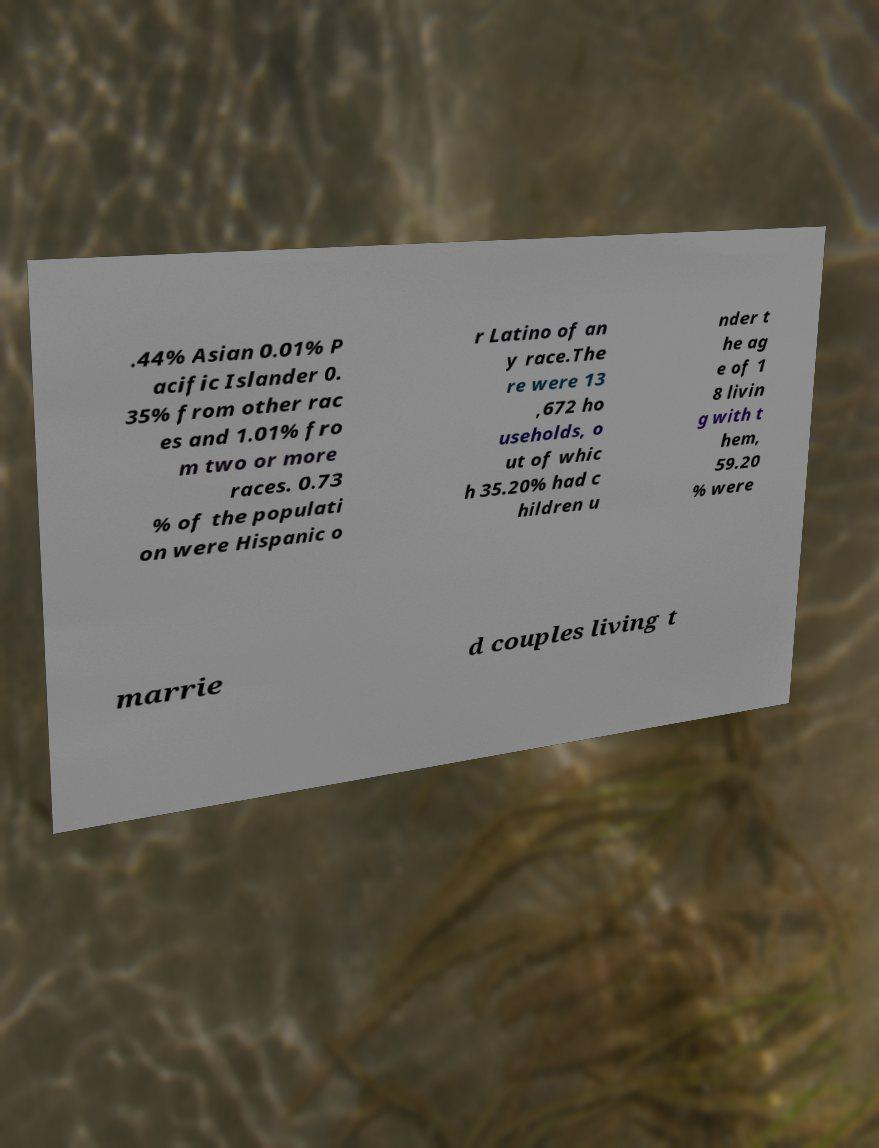Can you read and provide the text displayed in the image?This photo seems to have some interesting text. Can you extract and type it out for me? .44% Asian 0.01% P acific Islander 0. 35% from other rac es and 1.01% fro m two or more races. 0.73 % of the populati on were Hispanic o r Latino of an y race.The re were 13 ,672 ho useholds, o ut of whic h 35.20% had c hildren u nder t he ag e of 1 8 livin g with t hem, 59.20 % were marrie d couples living t 